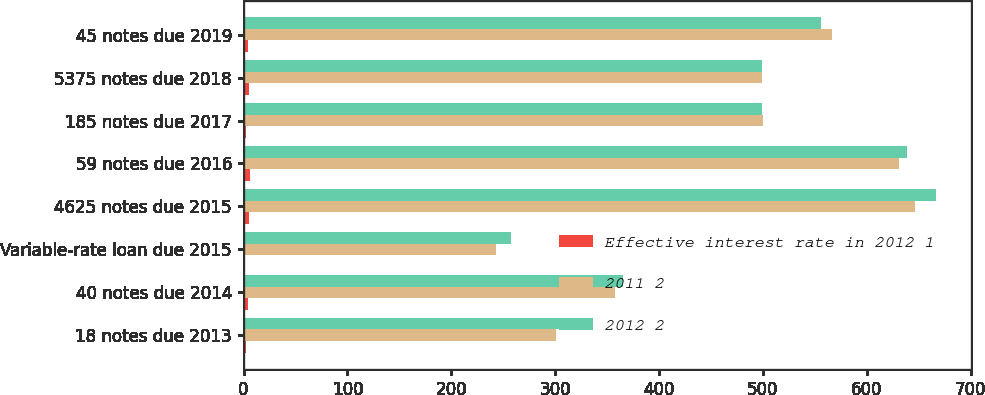Convert chart. <chart><loc_0><loc_0><loc_500><loc_500><stacked_bar_chart><ecel><fcel>18 notes due 2013<fcel>40 notes due 2014<fcel>Variable-rate loan due 2015<fcel>4625 notes due 2015<fcel>59 notes due 2016<fcel>185 notes due 2017<fcel>5375 notes due 2018<fcel>45 notes due 2019<nl><fcel>Effective interest rate in 2012 1<fcel>2<fcel>4.2<fcel>0.9<fcel>4.8<fcel>6<fcel>2<fcel>5.5<fcel>4.6<nl><fcel>2011 2<fcel>301<fcel>358<fcel>243<fcel>646<fcel>631<fcel>500<fcel>499<fcel>566<nl><fcel>2012 2<fcel>305<fcel>365<fcel>257<fcel>667<fcel>639<fcel>499<fcel>499<fcel>556<nl></chart> 